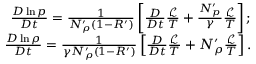Convert formula to latex. <formula><loc_0><loc_0><loc_500><loc_500>\begin{array} { r } { \frac { D \ln p } { D t } = \frac { 1 } { N _ { \rho } ^ { \prime } ( 1 - R ^ { \prime } ) } \left [ \frac { D } { D t } \frac { \mathcal { L } } { T } + \frac { N _ { p } ^ { \prime } } { \gamma } \frac { \mathcal { L } } { T } \right ] ; } \\ { \frac { D \ln \rho } { D t } = \frac { 1 } { \gamma N _ { \rho } ^ { \prime } ( 1 - R ^ { \prime } ) } \left [ \frac { D } { D t } \frac { \mathcal { L } } { T } + N _ { \rho } ^ { \prime } \frac { \mathcal { L } } { T } \right ] . } \end{array}</formula> 